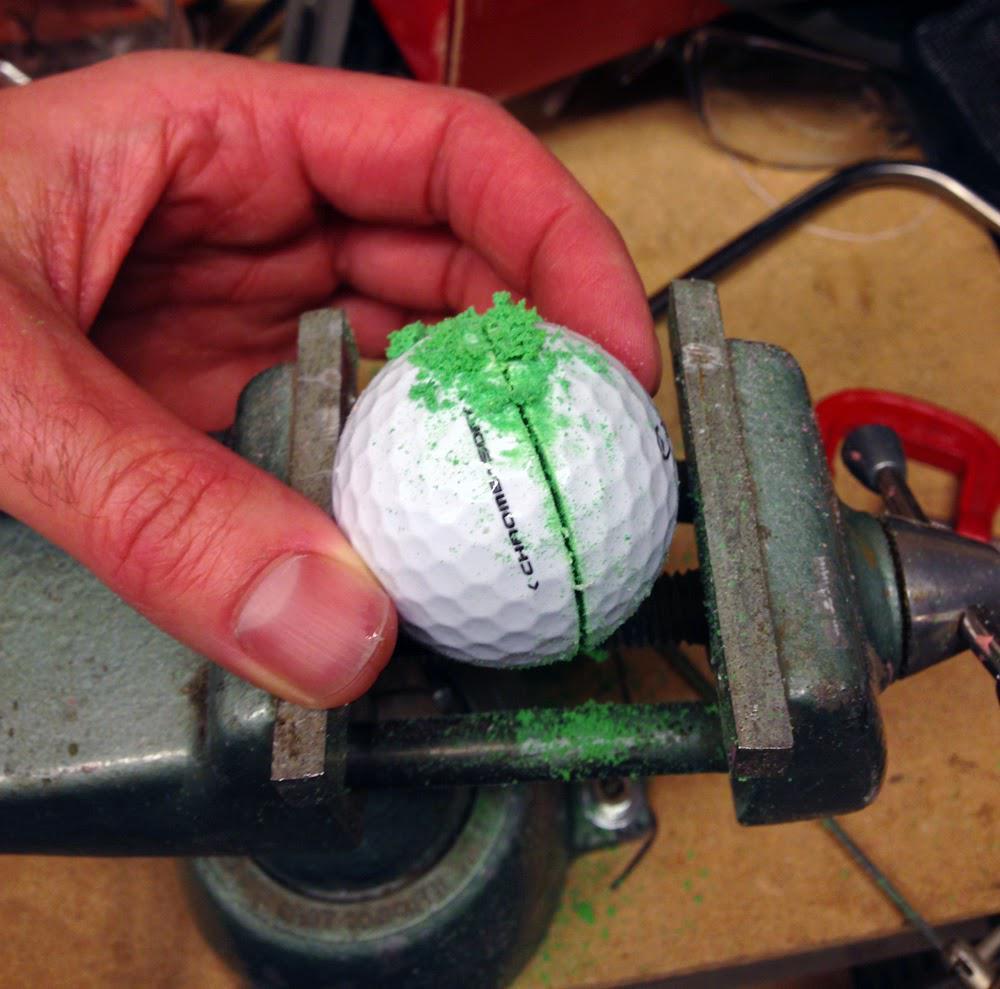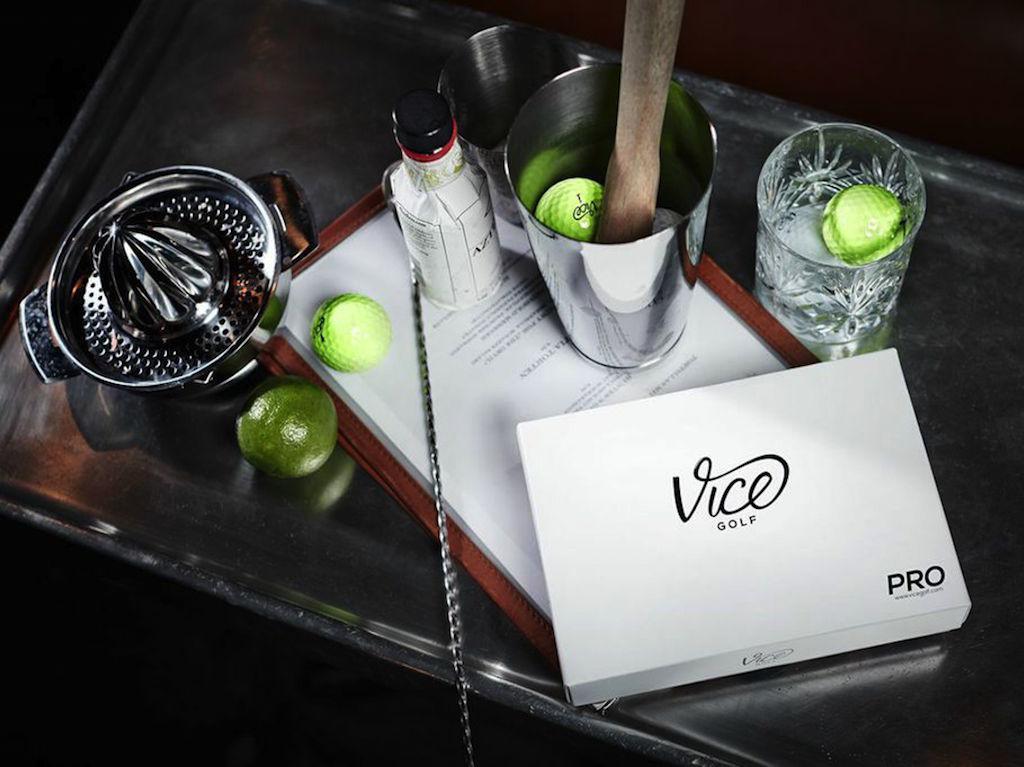The first image is the image on the left, the second image is the image on the right. Given the left and right images, does the statement "There are both green and white golfballs." hold true? Answer yes or no. Yes. The first image is the image on the left, the second image is the image on the right. Examine the images to the left and right. Is the description "Both pictures contain what appear to be the same single golf ball." accurate? Answer yes or no. No. 